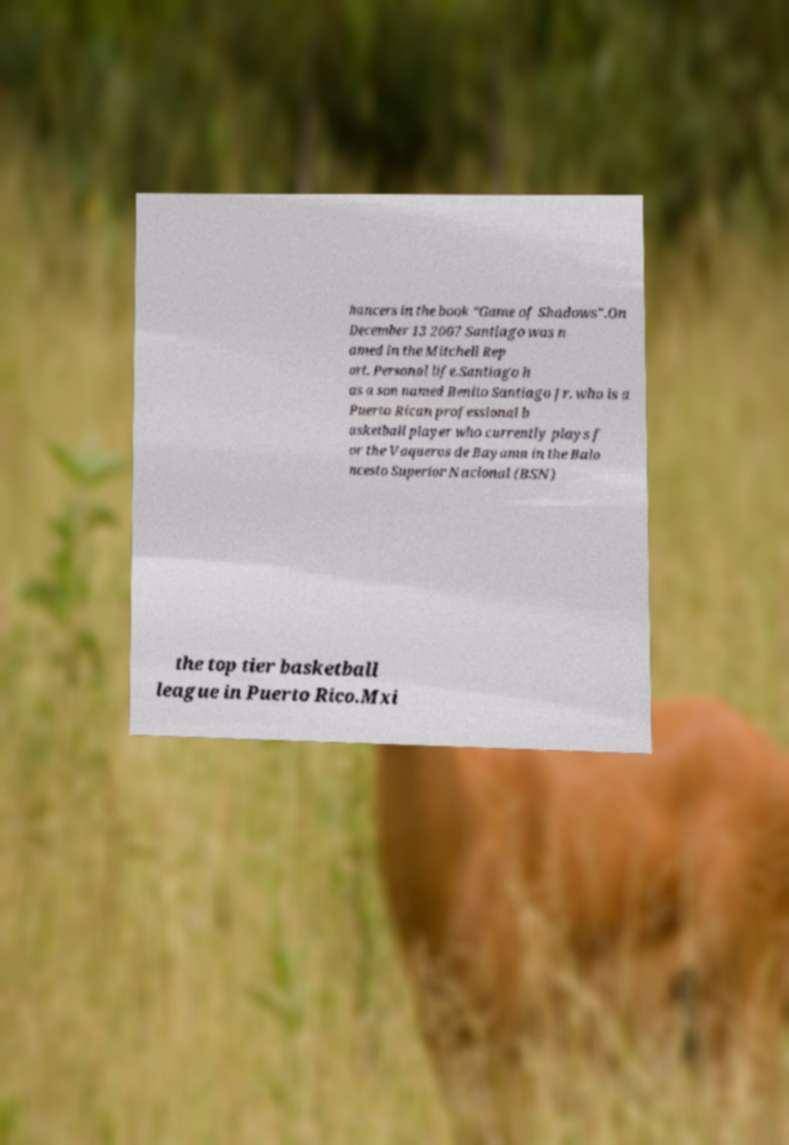Can you accurately transcribe the text from the provided image for me? hancers in the book "Game of Shadows".On December 13 2007 Santiago was n amed in the Mitchell Rep ort. Personal life.Santiago h as a son named Benito Santiago Jr. who is a Puerto Rican professional b asketball player who currently plays f or the Vaqueros de Bayamn in the Balo ncesto Superior Nacional (BSN) the top tier basketball league in Puerto Rico.Mxi 